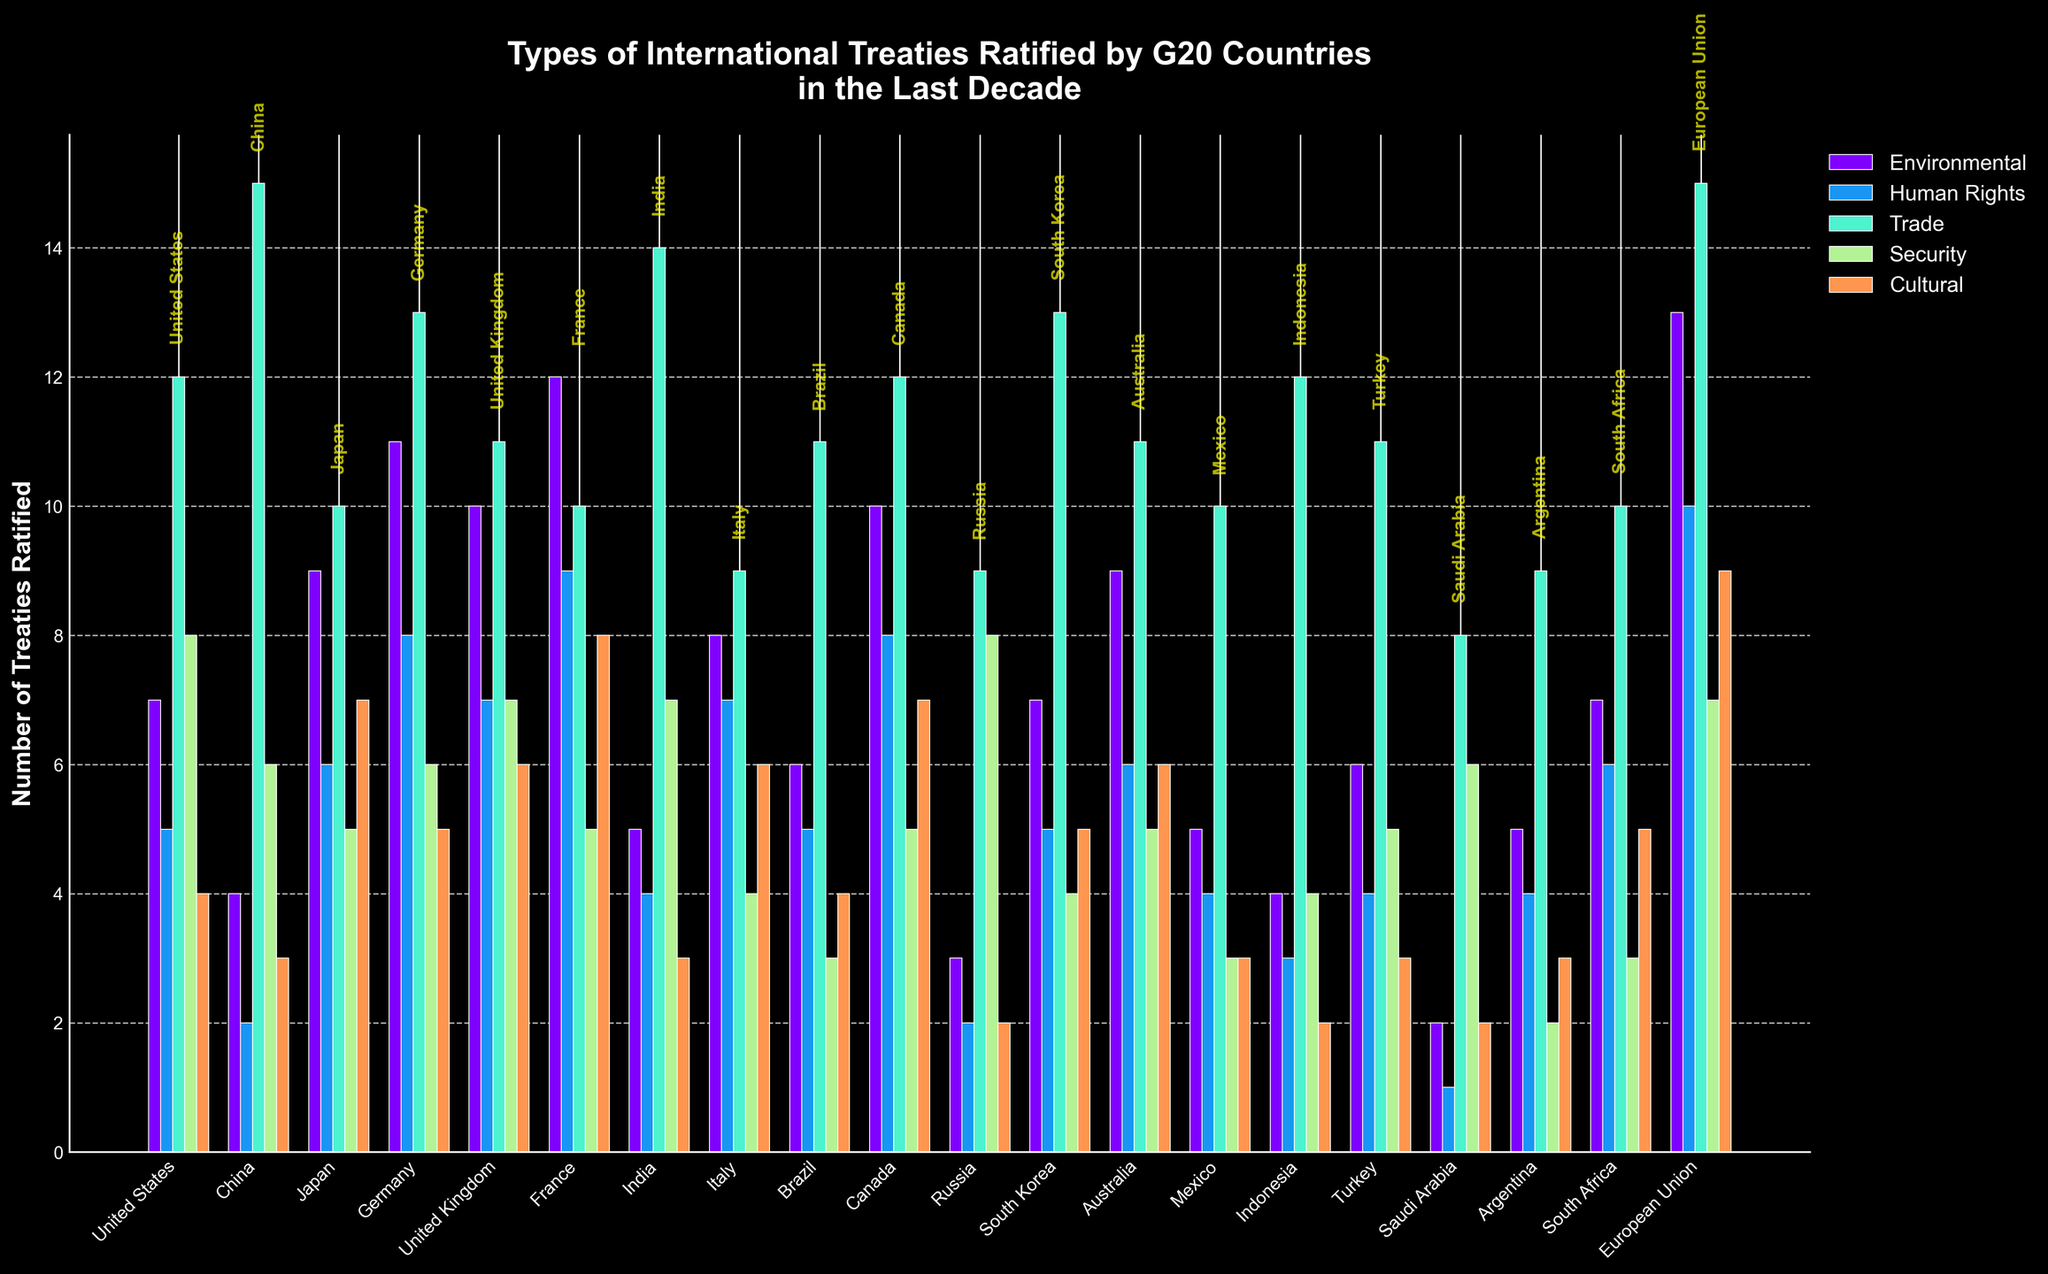What is the total number of Environmental treaties ratified by the United States and China? First, find the number of Environmental treaties ratified by the United States (7) and by China (4). Then, sum these two numbers: 7 + 4 = 11.
Answer: 11 Which country has ratified the most Human Rights treaties? Look at the height of the bars for Human Rights treaties (colored differently) and identify the country with the highest bar. The European Union has the highest bar at 10 treaties.
Answer: European Union Does Germany have more Security treaties ratified than Russia? Compare the heights of the bars for Security treaties for Germany and Russia. Germany's bar for Security treaties is at 6, while Russia's bar is at 8. Germany has fewer Security treaties ratified than Russia.
Answer: No Which three countries have ratified the highest number of Cultural treaties? Look at the bars for Cultural treaties and identify the heights for each country. The three highest bars are for the European Union (9), France (8), and Japan/Canada (7 each).
Answer: European Union, France, Japan/Canada Among G20 countries, how many have ratified exactly 6 Environmental treaties? Identify the countries with Environmental treaty bars at the height of 6: Australia (9), Mexico (5), Argentina (5), United Kingdom (10). None of them have exactly 6 Environmental treaties.
Answer: 0 What is the average number of Trade treaties ratified by G20 countries? Sum the number of Trade treaties ratified by each country and divide by the total number of countries (19 G20 countries + 1 EU). Sum: 12+15+10+13+11+10+14+9+11+12+9+13+11+10+12+11+8+9+10+15 = 215. Average: 215/20 = 10.75.
Answer: 10.75 Which country has a higher number of Human Rights treaties ratified: Italy or South Africa? Look at the bars for Human Rights treaties for Italy and South Africa. Italy has a bar at 7 treaties; South Africa has a bar at 6.
Answer: Italy What is the difference in the number of ratified Trade treaties between Saudi Arabia and India? Identify the number of Trade treaties ratified by Saudi Arabia (8) and by India (14). Then, subtract the smaller number from the larger: 14 - 8 = 6.
Answer: 6 True or False: The United States and Canada both have ratified the same number of Security treaties. Compare the heights of the Security treaty bars for the United States and Canada. Both have bars at the same height (5 each).
Answer: True What is the total number of treaties ratified by France across all types? Sum the heights of France's bars for Environmental (12), Human Rights (9), Trade (10), Security (5), and Cultural (8). Total: 12 + 9 + 10 + 5 + 8 = 44.
Answer: 44 